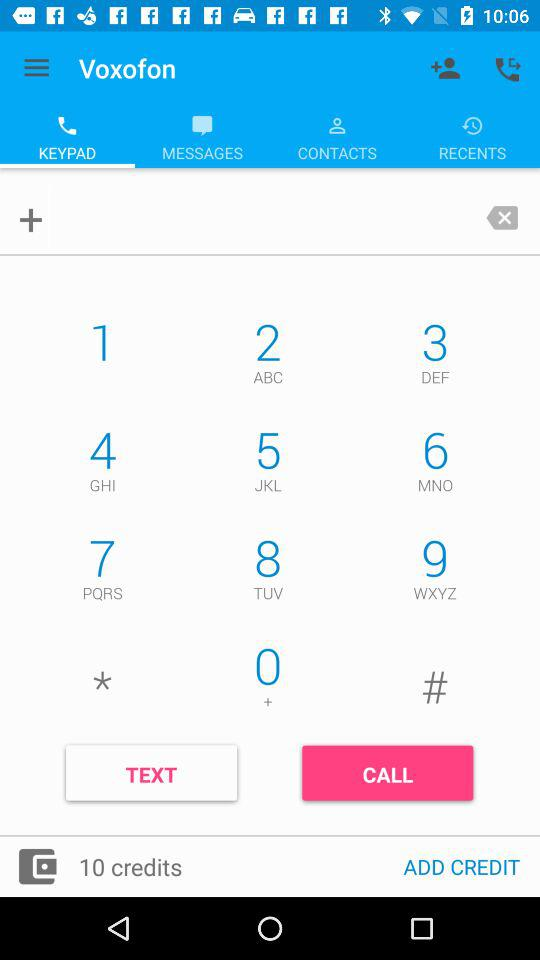How many credits are there? There are 10 credits. 